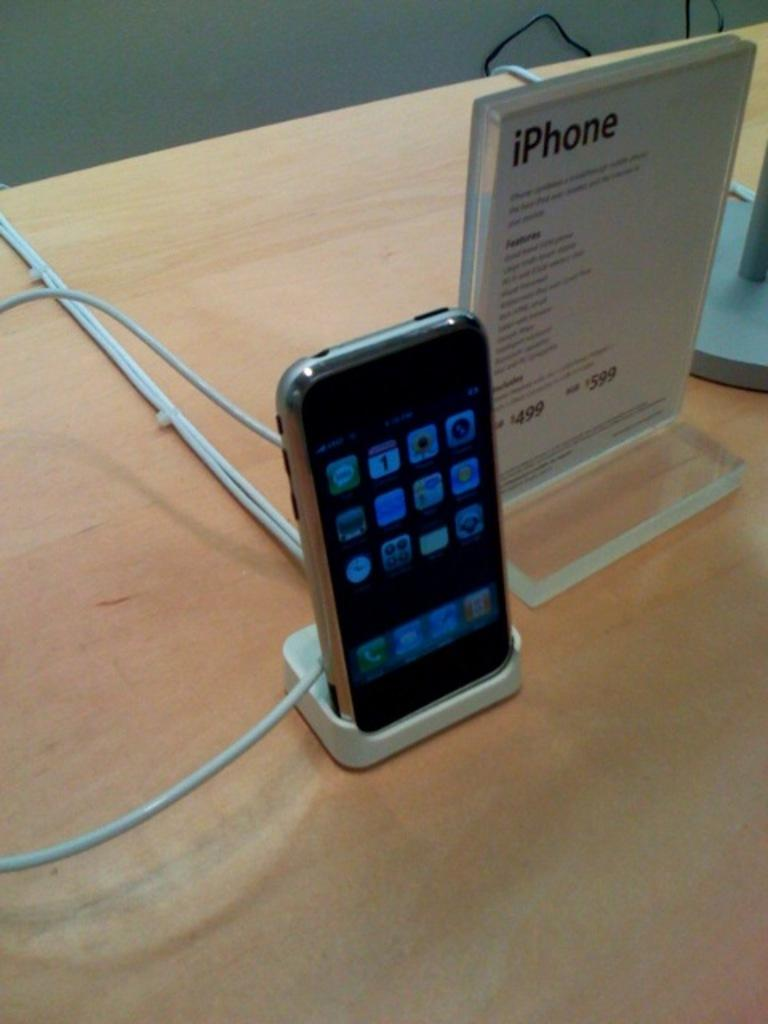<image>
Create a compact narrative representing the image presented. An iphone on a charging stand with a paper next to it that says 'iphone' 